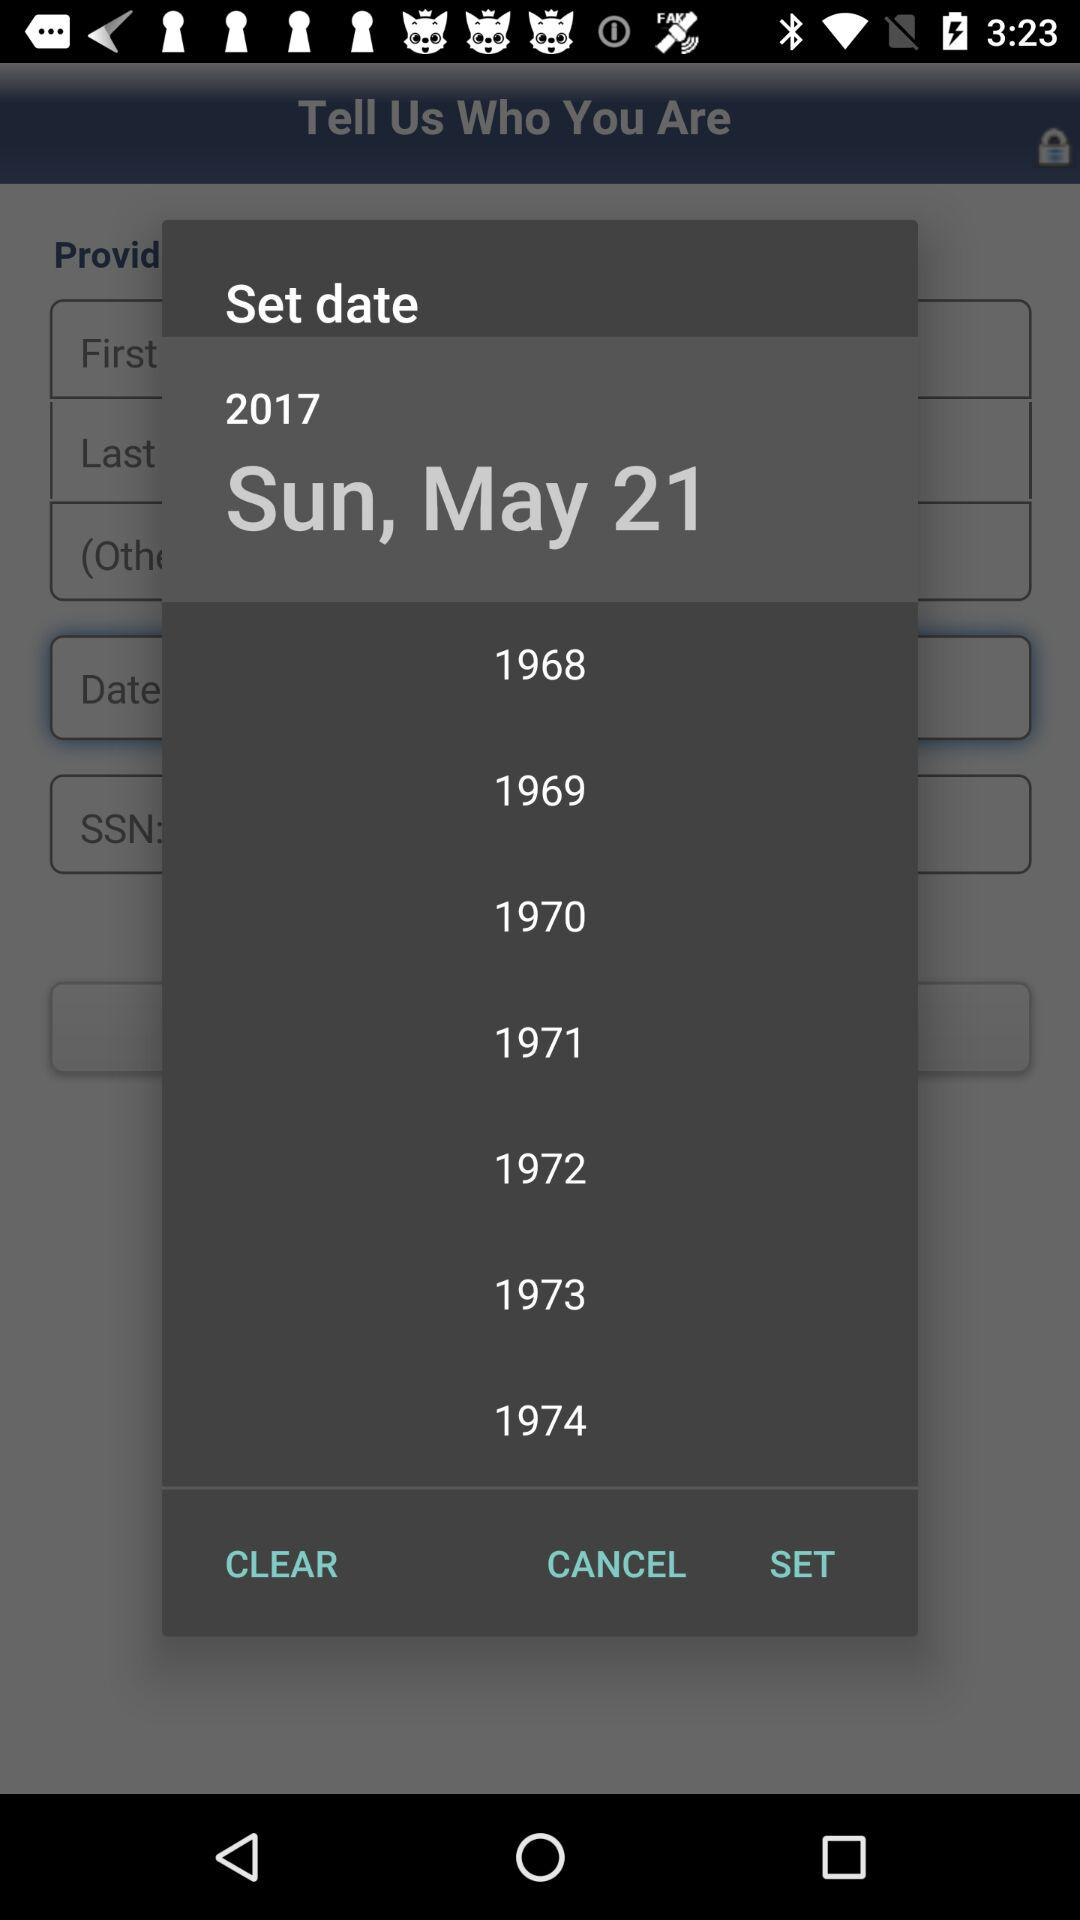What day is it on the selected date? The day is Sunday on the selected date. 